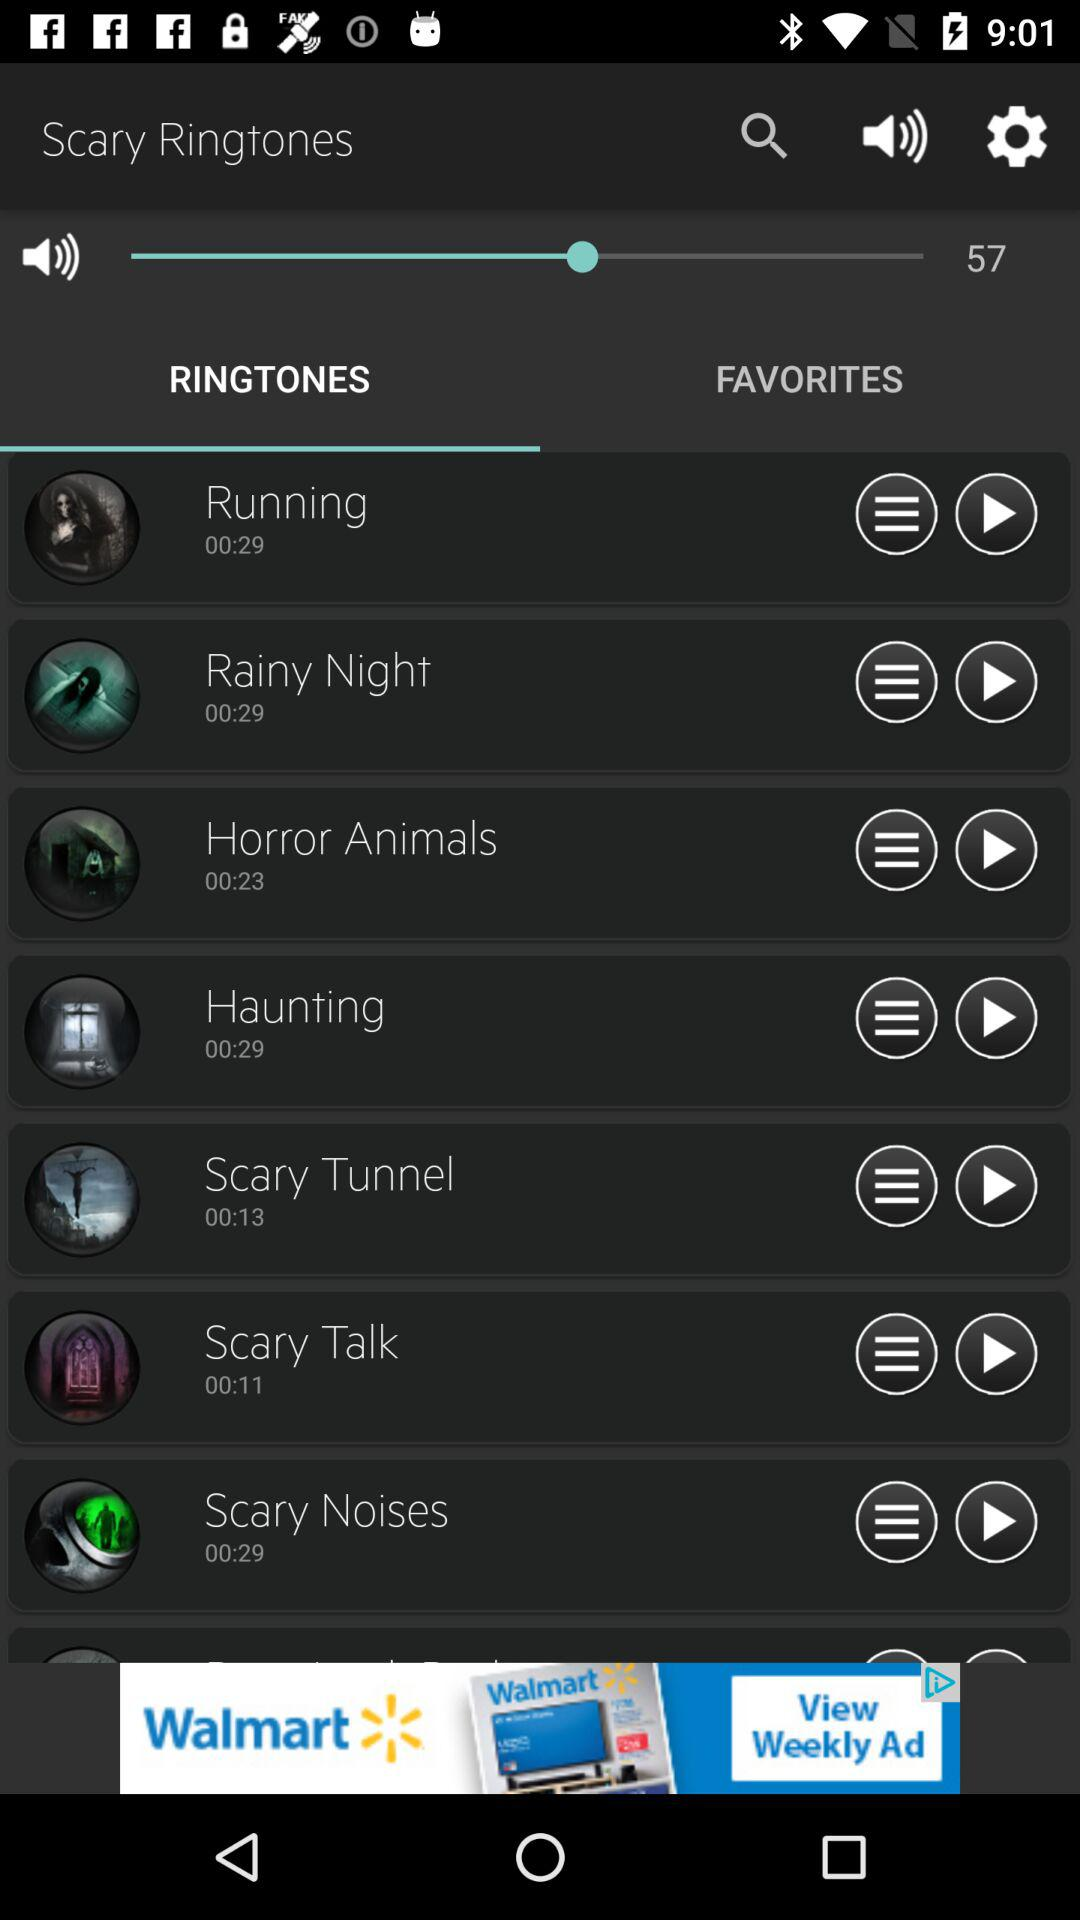Which option in "Scary Ringtones" is selected? The selected option is "RINGTONES". 